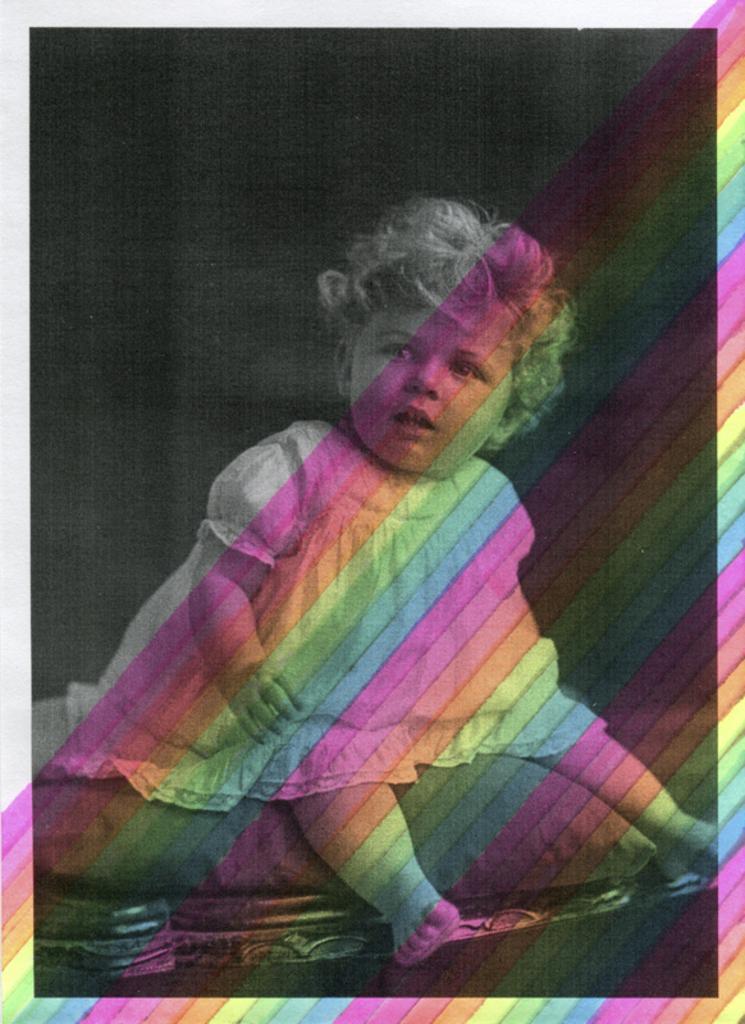Describe this image in one or two sentences. This is an edited image. In this image I can see a baby is sitting on a pillow which is placed on the bed. The background is in black color. 